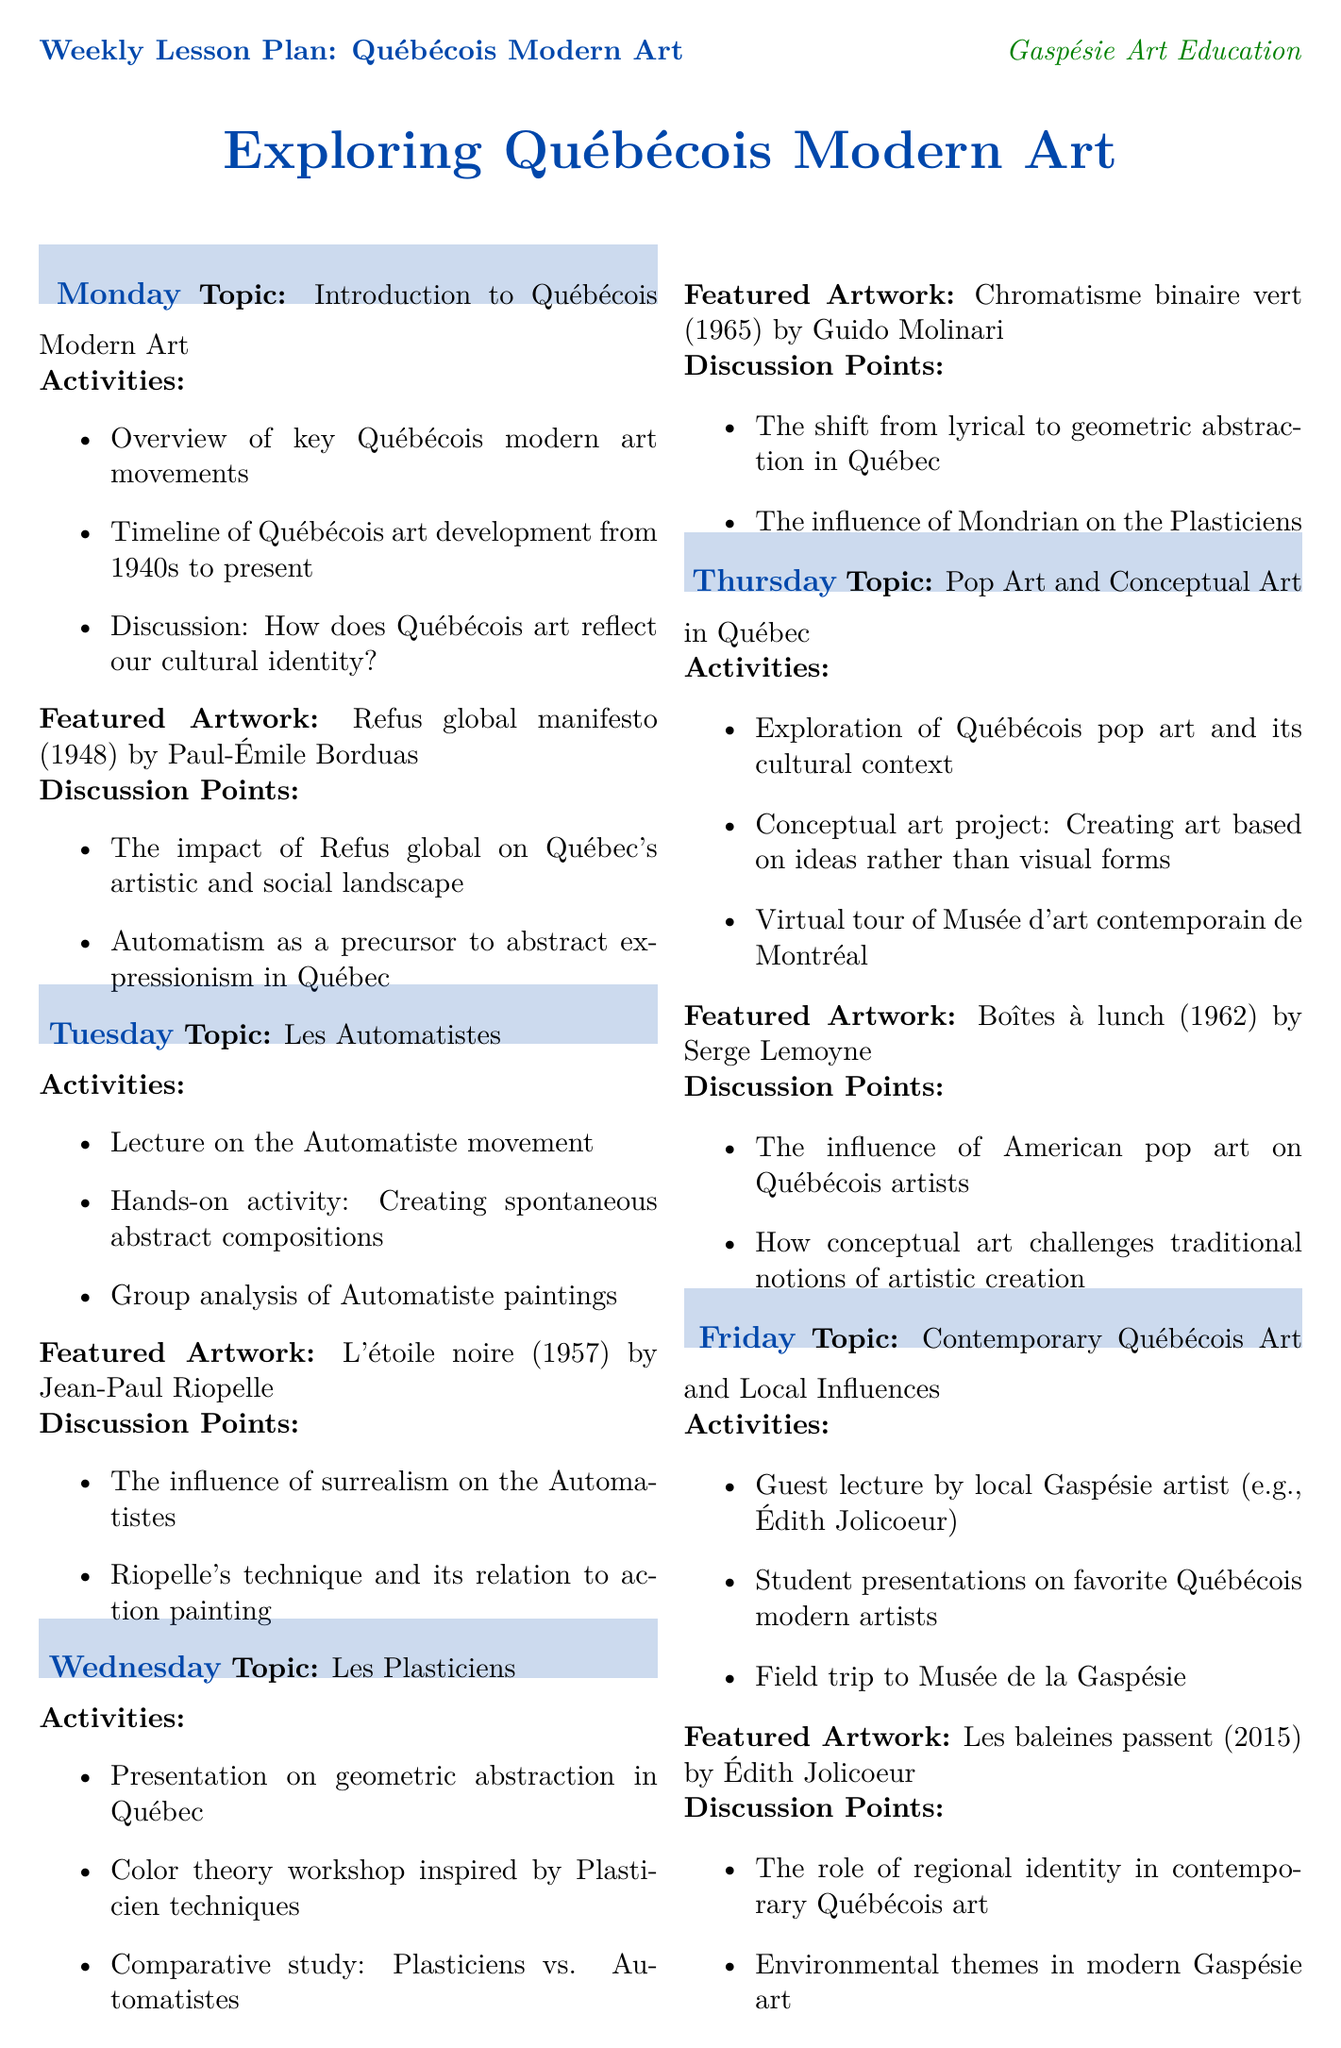What is the topic for Monday? The topic for Monday is an overview of key Québécois modern art movements.
Answer: Introduction to Québécois Modern Art Who is the artist of the featured artwork on Tuesday? The document lists Jean-Paul Riopelle as the artist of the featured artwork on Tuesday.
Answer: Jean-Paul Riopelle What year was the "L'étoile noire" created? "L'étoile noire" was created in 1957, as indicated in the schedule.
Answer: 1957 What type of art movement is discussed on Wednesday? The art movement discussed on Wednesday is geometric abstraction in Québec.
Answer: Les Plasticiens Which artwork is highlighted on Friday? The artwork highlighted on Friday is "Les baleines passent."
Answer: Les baleines passent What is one of the discussion points for the Thursday topic? The document mentions how conceptual art challenges traditional notions of artistic creation as a discussion point.
Answer: How conceptual art challenges traditional notions of artistic creation How many days are dedicated to exploring Québécois modern art movements? The weekly lesson plan outlines activities for five days focusing on this topic.
Answer: Five days What is an assessment idea mentioned in the document? One assessment idea includes creating a mixed-media artwork inspired by a modern art movement.
Answer: Create a mixed-media artwork inspired by a Québécois modern art movement What cultural context is explored during the Thursday lesson? The lesson explores Québécois pop art and its cultural context.
Answer: Québécois pop art and its cultural context 